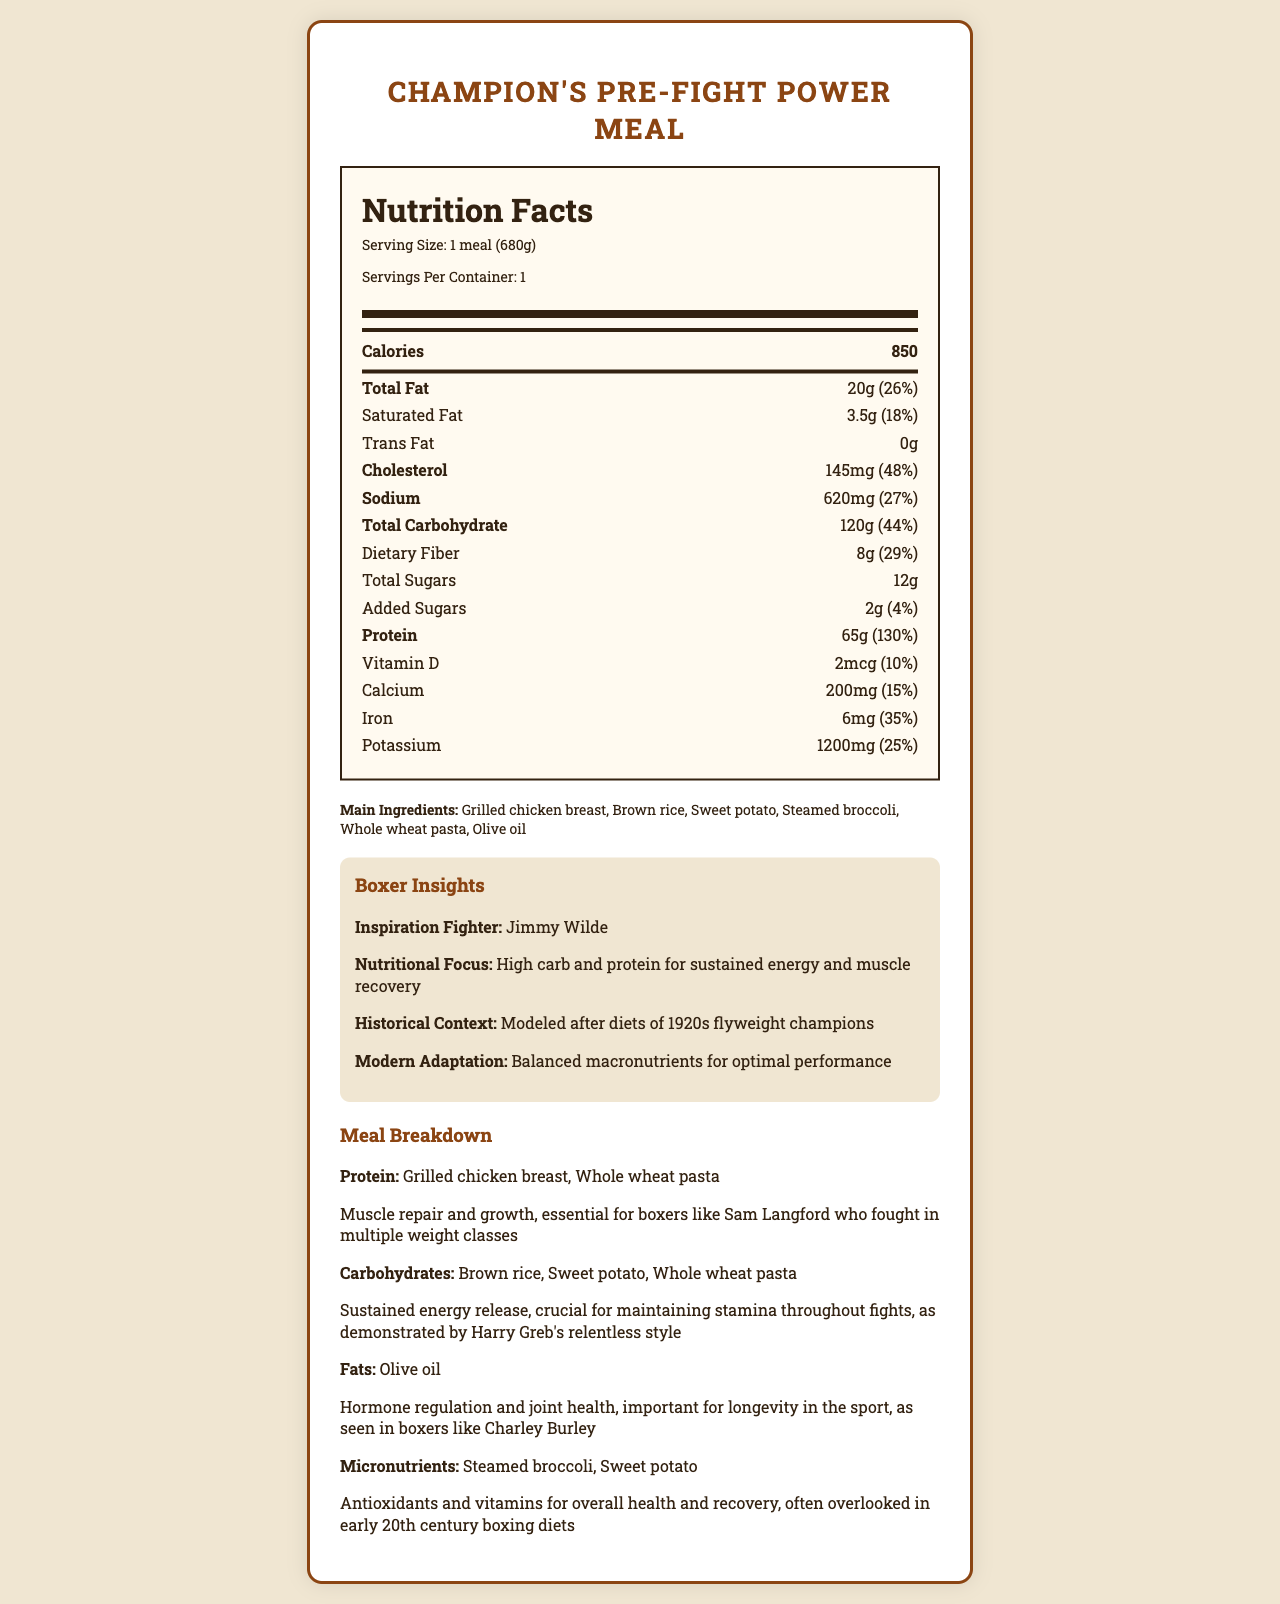what is the serving size of the Champion's Pre-Fight Power Meal? The serving size is mentioned under the nutrition facts header as "1 meal (680g)."
Answer: 1 meal (680g) how much protein is in one serving of the meal? The nutrition label lists 65g of protein per serving, which also accounts for 130% of the daily value.
Answer: 65g what are the main carbohydrate sources in the meal? According to the meal breakdown section, the main carbohydrate sources are Brown rice, Sweet potato, and Whole wheat pasta.
Answer: Brown rice, Sweet potato, Whole wheat pasta what is the percent daily value of total carbohydrates? The nutrition label specifies that the total carbohydrate content is 120g, which is 44% of the daily value.
Answer: 44% how many grams of dietary fiber does the meal contain? The nutrition label shows that the meal contains 8g of dietary fiber, which is 29% of the daily value.
Answer: 8g which fighter’s diet is the meal modeled after? The boxer insights section states that the meal is inspired by diets of 1920s flyweight champions, particularly Jimmy Wilde.
Answer: Jimmy Wilde the meal is intended to help with which two main areas for boxers? The nutritional focus in the Boxer Insights section mentions that the meal aims for high carb and protein content for sustained energy and muscle recovery.
Answer: Sustained energy and muscle recovery what are the benefits of the fats included in the meal? The meal breakdown section highlights Olive oil as the fat source, which aids in hormone regulation and joint health.
Answer: Hormone regulation and joint health multiple-choice: How many servings per container are there? I. 1 II. 2 III. 3 IV. 4 The document clearly notes that there is 1 serving per container.
Answer: I. 1 multiple-choice: Which of these is NOT an ingredient in the meal? A. Grilled chicken breast B. White rice C. Steamed broccoli D. Olive oil The list of main ingredients mentions brown rice, but not white rice.
Answer: B. White rice is there any trans fat in the meal? The nutrition label under trans fat shows "0g," indicating there is no trans fat in the meal.
Answer: No summarize the main idea of the document. The nutrition label offers a breakdown of calories, macronutrients, and micronutrients, while additional sections elaborate on the main ingredients, historical inspirations, and modern adaptions for boxers.
Answer: The document provides detailed nutritional information about the Champion's Pre-Fight Power Meal, highlighting its high protein and carbohydrate content for optimal boxer performance. It also includes ingredients, boxer insights, and benefits of each nutrient type. what is the exact amount of added sugars in the meal? The nutritional label under added sugars shows an amount of 2g, which comprises 4% of the daily value.
Answer: 2g what are the main ingredients in this meal? The main ingredients listed include Grilled chicken breast, Brown rice, Sweet potato, Steamed broccoli, Whole wheat pasta, and Olive oil.
Answer: Grilled chicken breast, Brown rice, Sweet potato, Steamed broccoli, Whole wheat pasta, Olive oil what historical context is provided for the meal? The document states that the meal is modeled after the diets of 1920s flyweight champions.
Answer: Modeled after diets of 1920s flyweight champions what is the problem this meal is trying to solve? The document does not provide specific information about a particular problem it seeks to address, other than general nutritional benefits.
Answer: Not enough information what is the amount of total sugars in the meal? The nutrition label indicates that the total sugar content in the meal is 12g.
Answer: 12g 